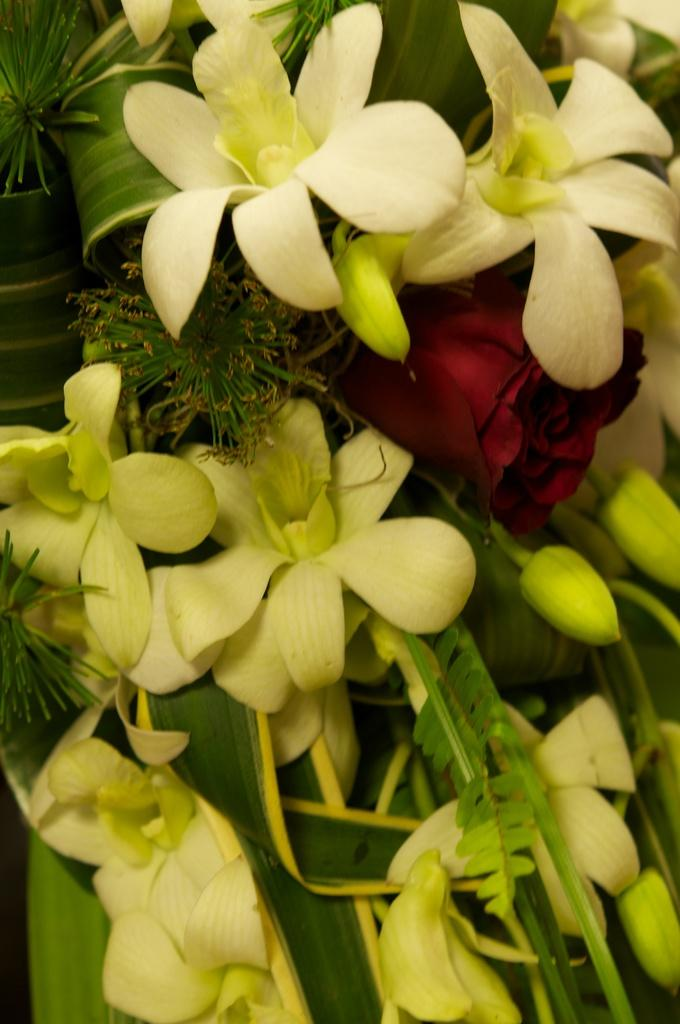What type of plants can be seen in the image? There are flowers and leaves in the image. Can you describe the appearance of the flowers? Unfortunately, the specific appearance of the flowers cannot be determined from the provided facts. Are there any other elements present in the image besides the flowers and leaves? No additional elements are mentioned in the provided facts. What type of education does the porter in the image have? There is no porter present in the image, as the facts only mention flowers and leaves. 